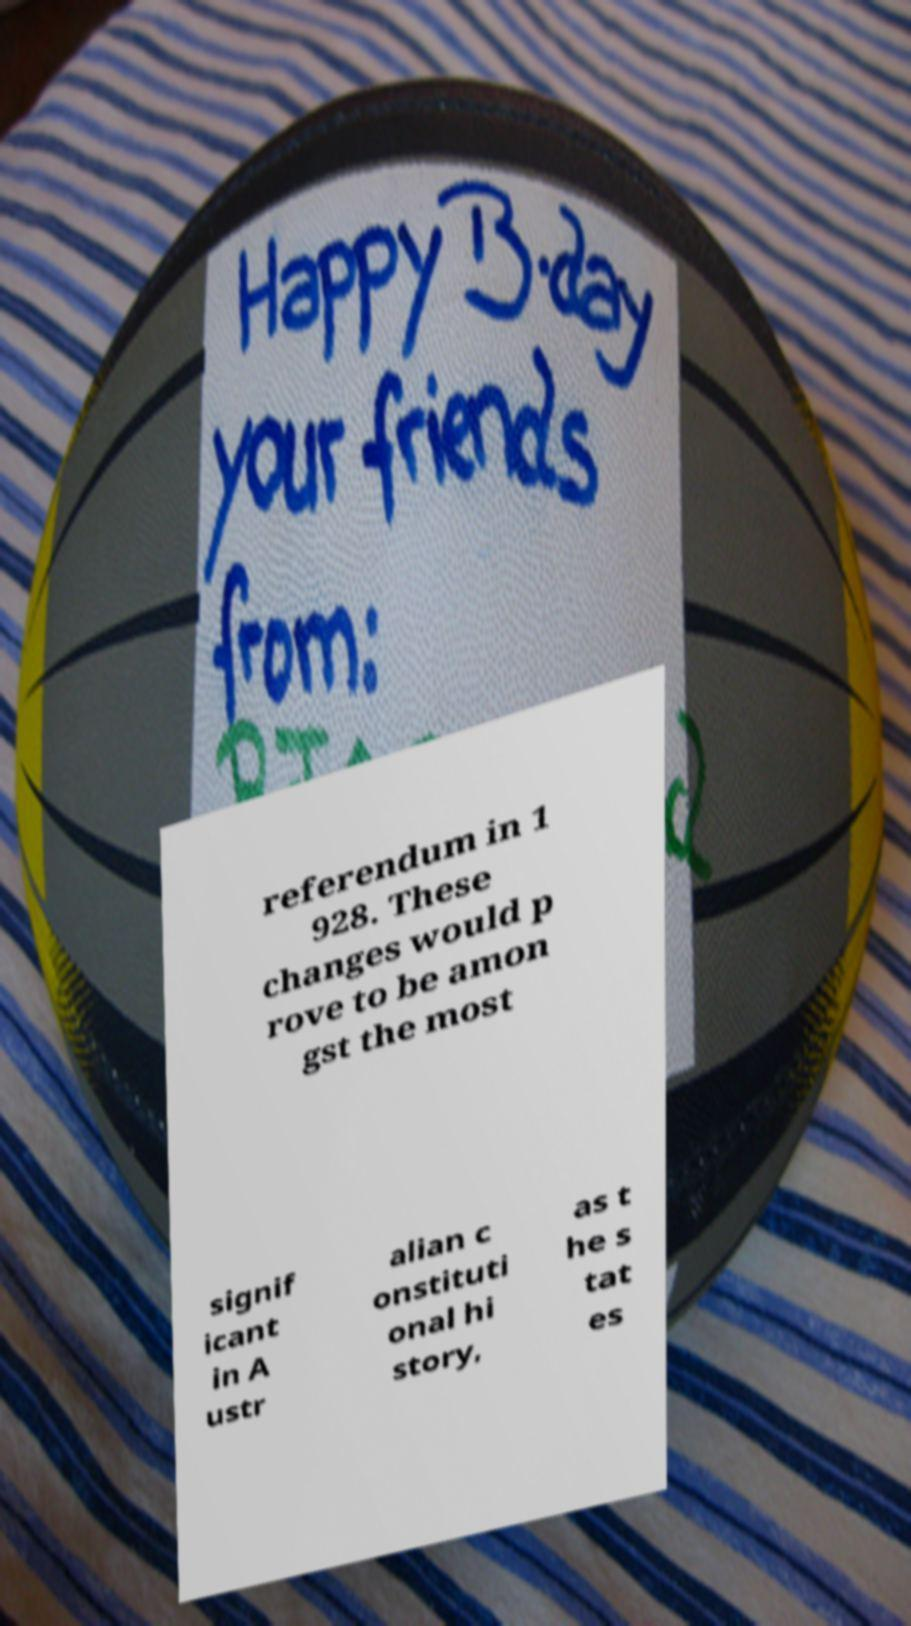Could you assist in decoding the text presented in this image and type it out clearly? referendum in 1 928. These changes would p rove to be amon gst the most signif icant in A ustr alian c onstituti onal hi story, as t he s tat es 